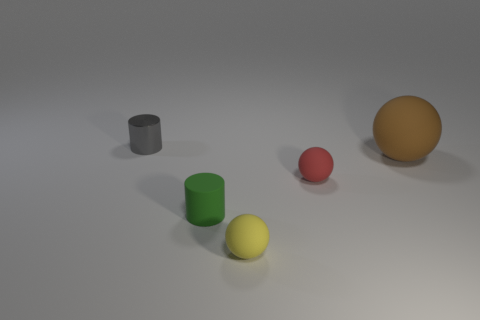There is a small cylinder right of the gray metallic object; is its color the same as the matte thing on the right side of the tiny red ball? no 